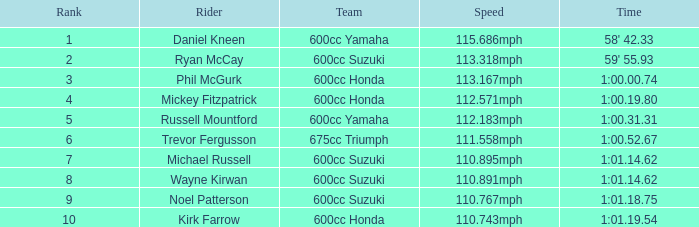What is the count of ranks for michael russell as a rider? 7.0. 